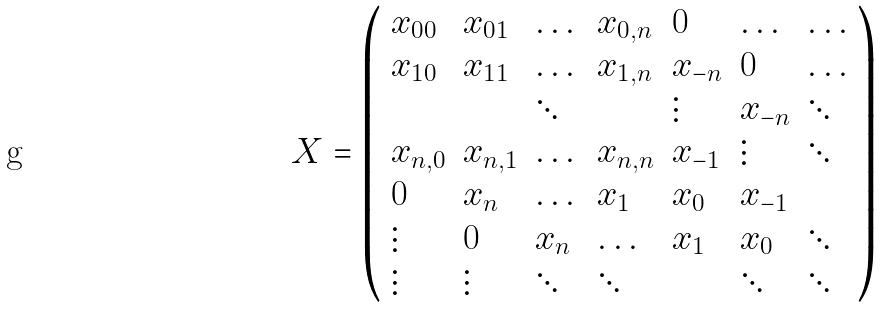Convert formula to latex. <formula><loc_0><loc_0><loc_500><loc_500>X = \left ( \begin{array} { l l l l l l l } x _ { 0 0 } & x _ { 0 1 } & \dots & x _ { 0 , n } & 0 & \dots & \dots \\ x _ { 1 0 } & x _ { 1 1 } & \dots & x _ { 1 , n } & x _ { - n } & 0 & \dots \\ & & \ddots & & \vdots & x _ { - n } & \ddots \\ x _ { n , 0 } & x _ { n , 1 } & \dots & x _ { n , n } & x _ { - 1 } & \vdots & \ddots \\ 0 & x _ { n } & \dots & x _ { 1 } & x _ { 0 } & x _ { - 1 } & \\ \vdots & 0 & x _ { n } & \dots & x _ { 1 } & x _ { 0 } & \ddots \\ \vdots & \vdots & \ddots & \ddots & & \ddots & \ddots \end{array} \right )</formula> 